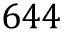Convert formula to latex. <formula><loc_0><loc_0><loc_500><loc_500>6 4 4</formula> 